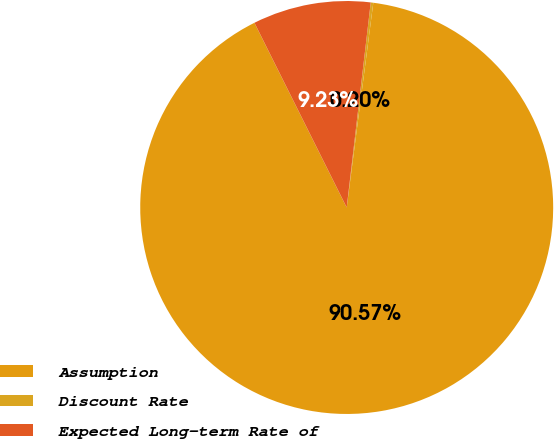Convert chart. <chart><loc_0><loc_0><loc_500><loc_500><pie_chart><fcel>Assumption<fcel>Discount Rate<fcel>Expected Long-term Rate of<nl><fcel>90.57%<fcel>0.2%<fcel>9.23%<nl></chart> 